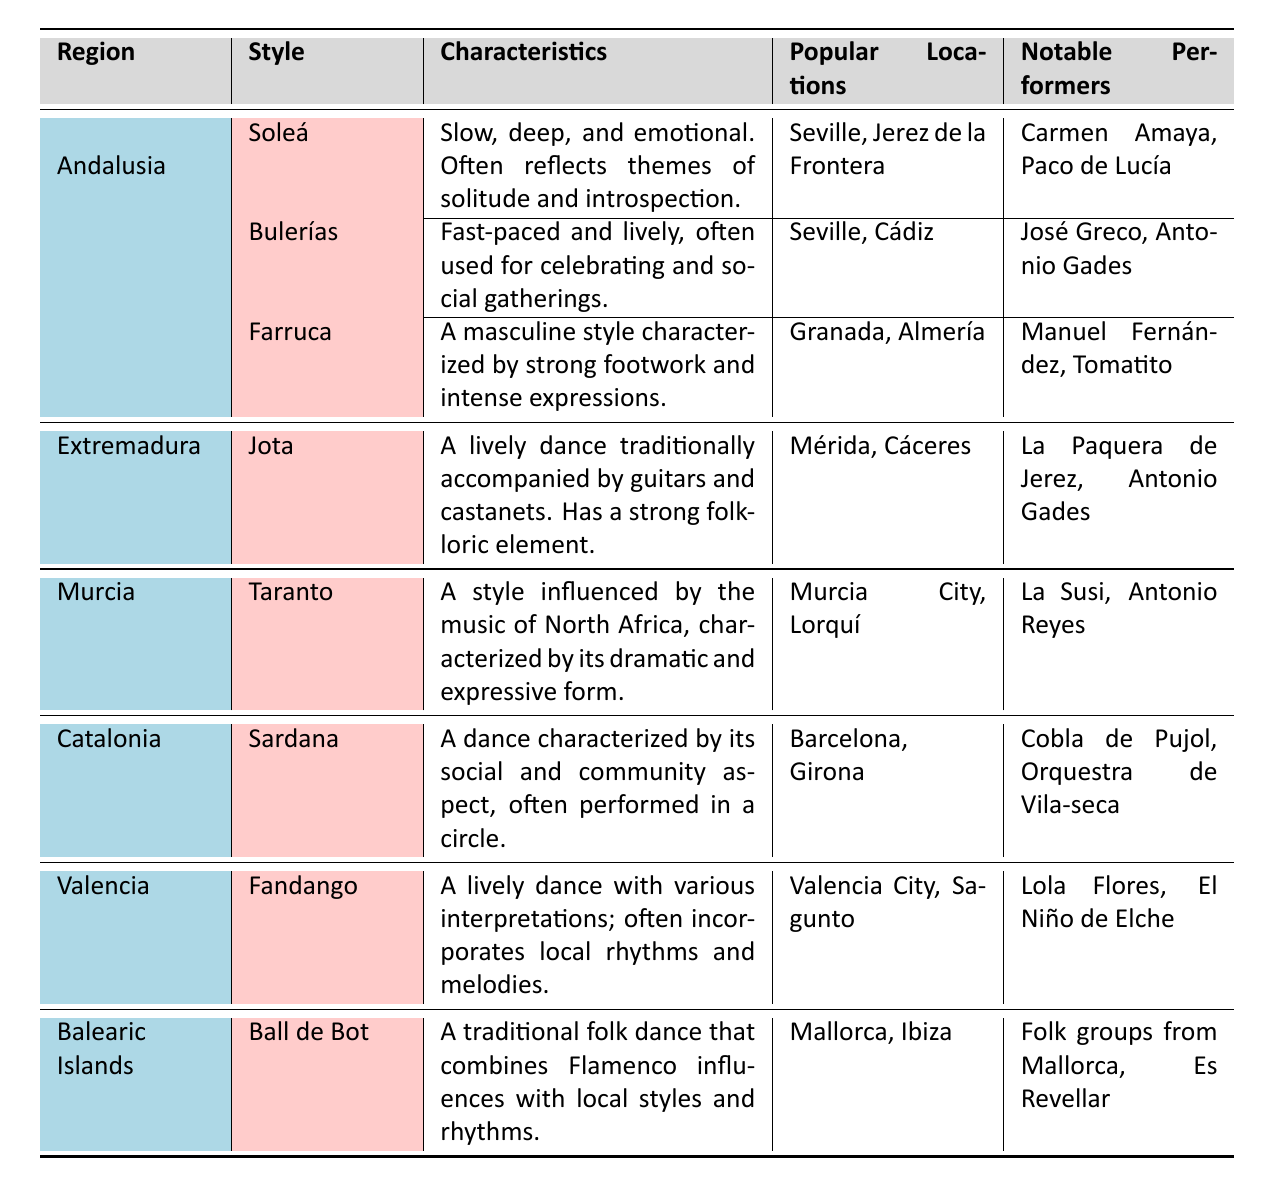What is the characteristic of the Soleá style? The table indicates that the Soleá style is described as slow, deep, and emotional, often reflecting themes of solitude and introspection.
Answer: Slow, deep, and emotional Which region is associated with the Jota dance style? According to the table, the Jota dance style is listed under the region of Extremadura.
Answer: Extremadura How many notable performers are listed for the Bulerías style? From the table, the Bulerías style has two notable performers listed: José Greco and Antonio Gades.
Answer: 2 What are the popular locations for the Farruca style? The table states that the popular locations for the Farruca style are Granada and Almería.
Answer: Granada, Almería Which Flamenco dance style is influenced by North African music? The style influenced by North African music, characterized by its dramatic and expressive form, is the Taranto according to the table.
Answer: Taranto In which regions is the Ball de Bot performed? The table lists the popular locations for the Ball de Bot style as Mallorca and Ibiza, which are in the Balearic Islands region.
Answer: Mallorca, Ibiza Which style has a strong folkloric element? The Jota style is noted in the table as having a strong folkloric element in its characteristics.
Answer: Jota Compare the number of notable performers for the Soleá and Bulerías styles. The Soleá style has two notable performers (Carmen Amaya and Paco de Lucía), while the Bulerías style also has two notable performers (José Greco and Antonio Gades), so there is no difference.
Answer: No difference Is there a dance style that is characterized by strong footwork and intense expressions? The table shows that the Farruca style is characterized by strong footwork and intense expressions.
Answer: Yes What is the average number of notable performers across all styles listed in the table? Total notable performers across styles: Soleá (2) + Bulerías (2) + Farruca (2) + Jota (2) + Taranto (2) + Sardana (2) + Fandango (2) + Ball de Bot (2) = 16. There are 8 styles, so average is 16/8 = 2.
Answer: 2 Which style involves social and community aspects during the dance? The Sardana style is highlighted in the table as being characterized by its social and community aspect, often performed in a circle.
Answer: Sardana 